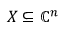Convert formula to latex. <formula><loc_0><loc_0><loc_500><loc_500>X \subseteq \mathbb { C } ^ { n }</formula> 